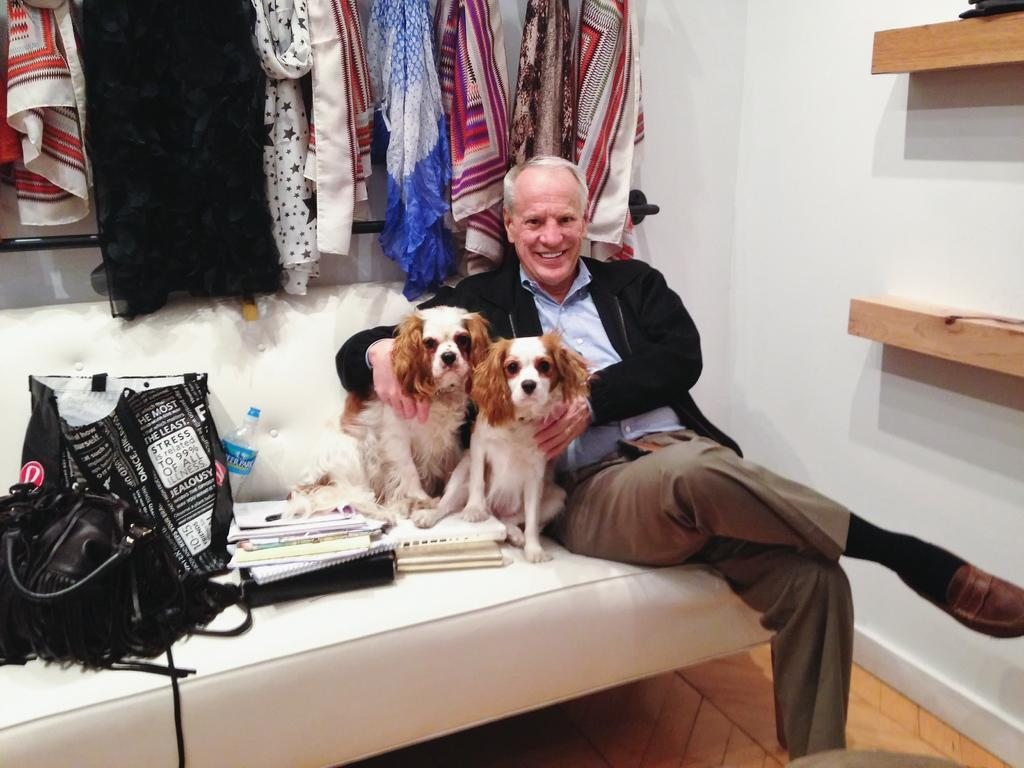Who is present in the image? There is a man in the image. What is the man doing in the image? The man is smiling in the image. Where is the man sitting in the image? The man is sitting on a sofa in the image. What else can be seen on the sofa? There are two dogs, bags, a bottle, and books on the sofa. What can be seen in the background of the image? There are clothes, a wall, and racks visible in the background. What type of truck is parked outside the window in the image? There is no truck visible in the image; it only shows a man sitting on a sofa with dogs, bags, a bottle, and books, along with a background featuring clothes, a wall, and racks. 